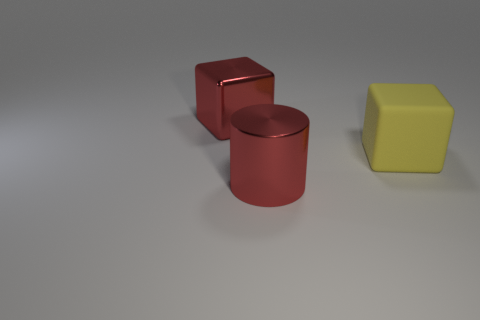Add 2 red cylinders. How many objects exist? 5 Subtract all cylinders. How many objects are left? 2 Subtract 1 cylinders. How many cylinders are left? 0 Add 2 large yellow cylinders. How many large yellow cylinders exist? 2 Subtract all yellow blocks. How many blocks are left? 1 Subtract 1 red cylinders. How many objects are left? 2 Subtract all brown cubes. Subtract all gray cylinders. How many cubes are left? 2 Subtract all big yellow metal cylinders. Subtract all large red objects. How many objects are left? 1 Add 2 big red metallic blocks. How many big red metallic blocks are left? 3 